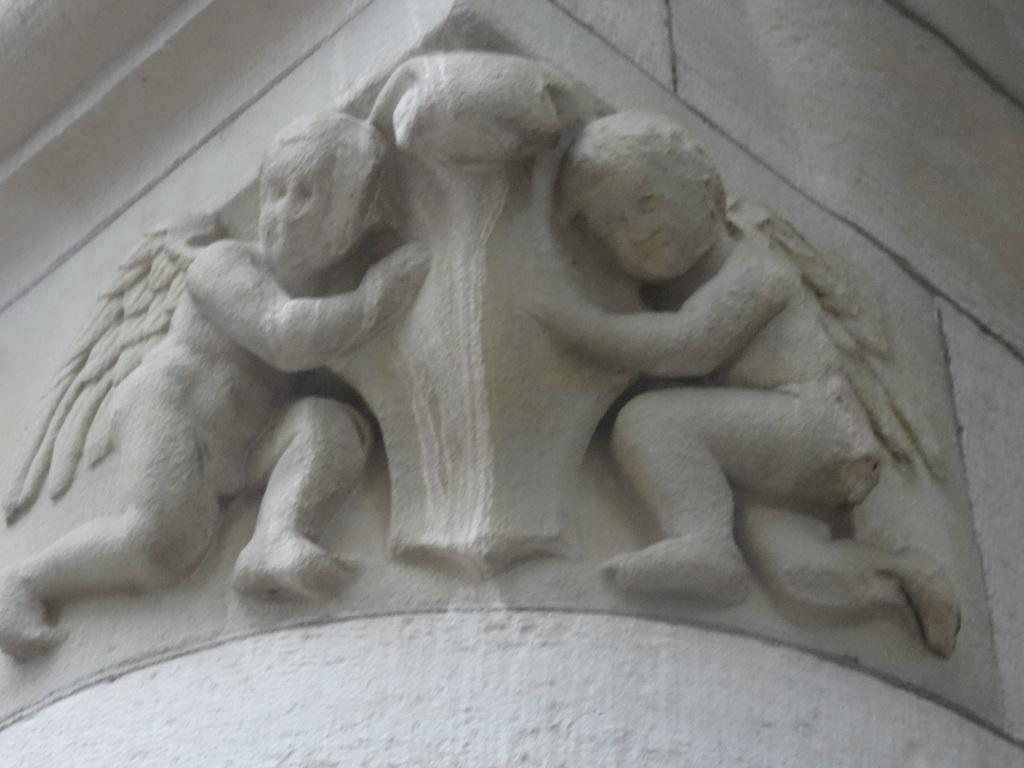What is depicted in the image? There are two sculptures in the image. What are the sculptures of? The sculptures are of angels. Where are the sculptures located? The sculptures are carved on a wall. How far apart are the two angels in the image? The provided facts do not mention the distance between the two angels, so we cannot determine their distance from the image. 